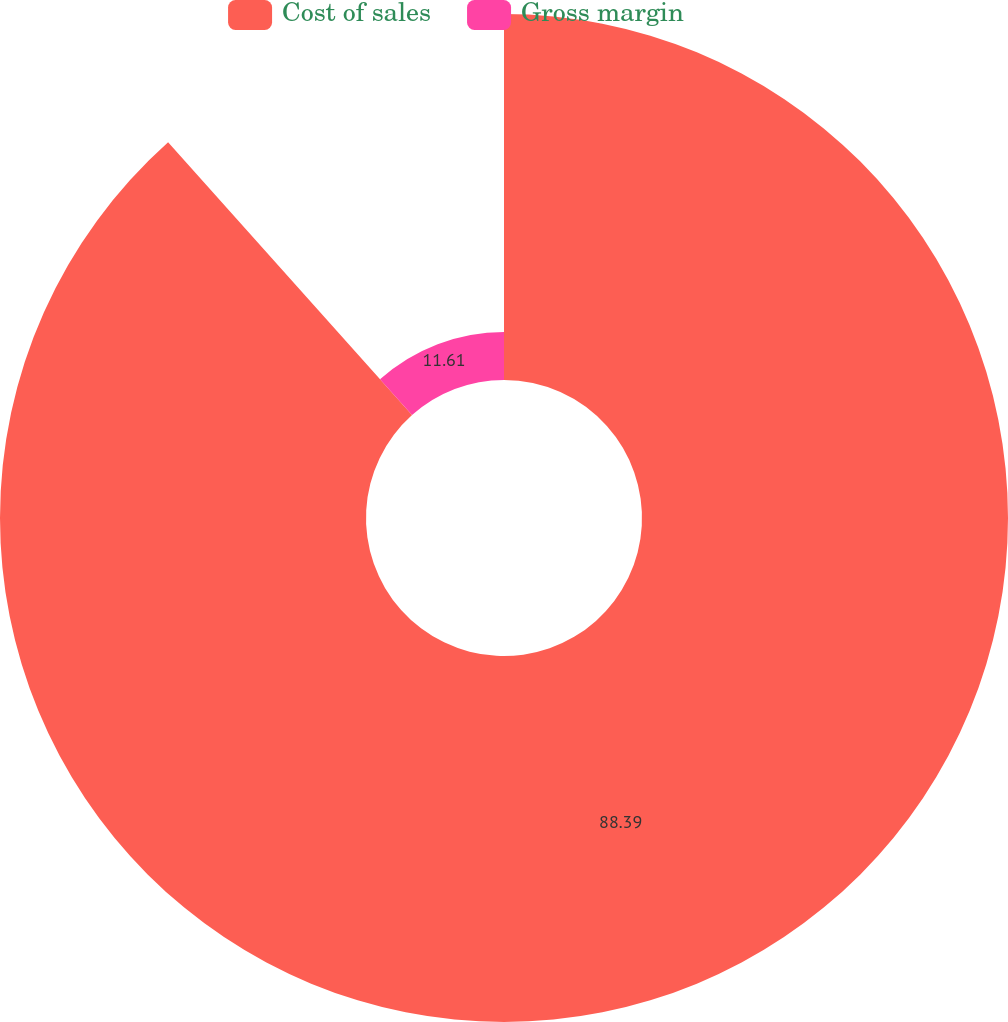<chart> <loc_0><loc_0><loc_500><loc_500><pie_chart><fcel>Cost of sales<fcel>Gross margin<nl><fcel>88.39%<fcel>11.61%<nl></chart> 